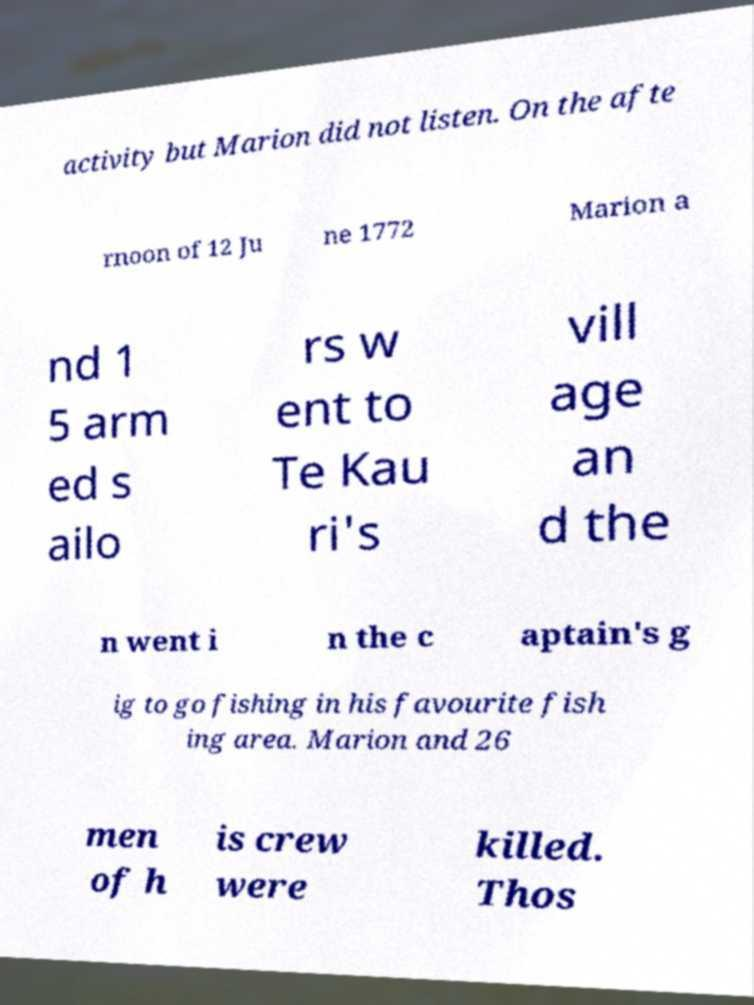Can you accurately transcribe the text from the provided image for me? activity but Marion did not listen. On the afte rnoon of 12 Ju ne 1772 Marion a nd 1 5 arm ed s ailo rs w ent to Te Kau ri's vill age an d the n went i n the c aptain's g ig to go fishing in his favourite fish ing area. Marion and 26 men of h is crew were killed. Thos 